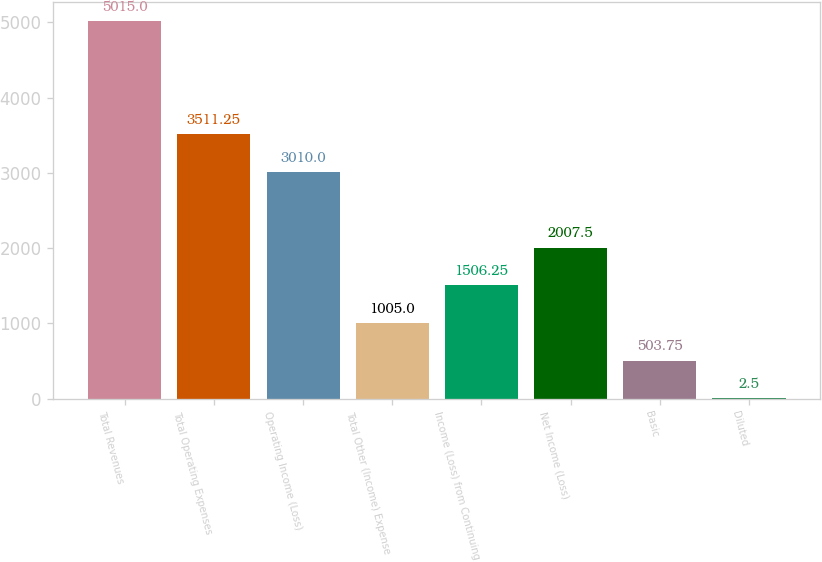<chart> <loc_0><loc_0><loc_500><loc_500><bar_chart><fcel>Total Revenues<fcel>Total Operating Expenses<fcel>Operating Income (Loss)<fcel>Total Other (Income) Expense<fcel>Income (Loss) from Continuing<fcel>Net Income (Loss)<fcel>Basic<fcel>Diluted<nl><fcel>5015<fcel>3511.25<fcel>3010<fcel>1005<fcel>1506.25<fcel>2007.5<fcel>503.75<fcel>2.5<nl></chart> 